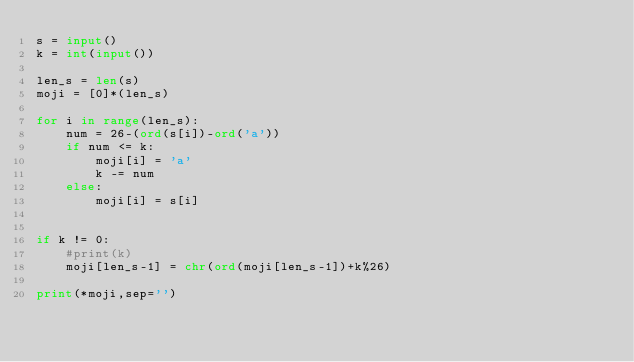<code> <loc_0><loc_0><loc_500><loc_500><_Python_>s = input()
k = int(input())

len_s = len(s)
moji = [0]*(len_s)

for i in range(len_s):
    num = 26-(ord(s[i])-ord('a'))
    if num <= k:
        moji[i] = 'a'
        k -= num
    else:
        moji[i] = s[i]

     
if k != 0:
    #print(k)
    moji[len_s-1] = chr(ord(moji[len_s-1])+k%26)
        
print(*moji,sep='')</code> 